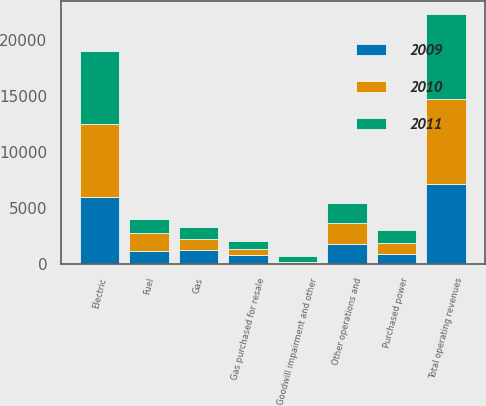Convert chart to OTSL. <chart><loc_0><loc_0><loc_500><loc_500><stacked_bar_chart><ecel><fcel>Electric<fcel>Gas<fcel>Total operating revenues<fcel>Fuel<fcel>Purchased power<fcel>Gas purchased for resale<fcel>Other operations and<fcel>Goodwill impairment and other<nl><fcel>2010<fcel>6530<fcel>1001<fcel>7531<fcel>1567<fcel>966<fcel>570<fcel>1820<fcel>125<nl><fcel>2011<fcel>6521<fcel>1117<fcel>7638<fcel>1323<fcel>1106<fcel>669<fcel>1821<fcel>589<nl><fcel>2009<fcel>5940<fcel>1195<fcel>7135<fcel>1141<fcel>909<fcel>749<fcel>1768<fcel>7<nl></chart> 